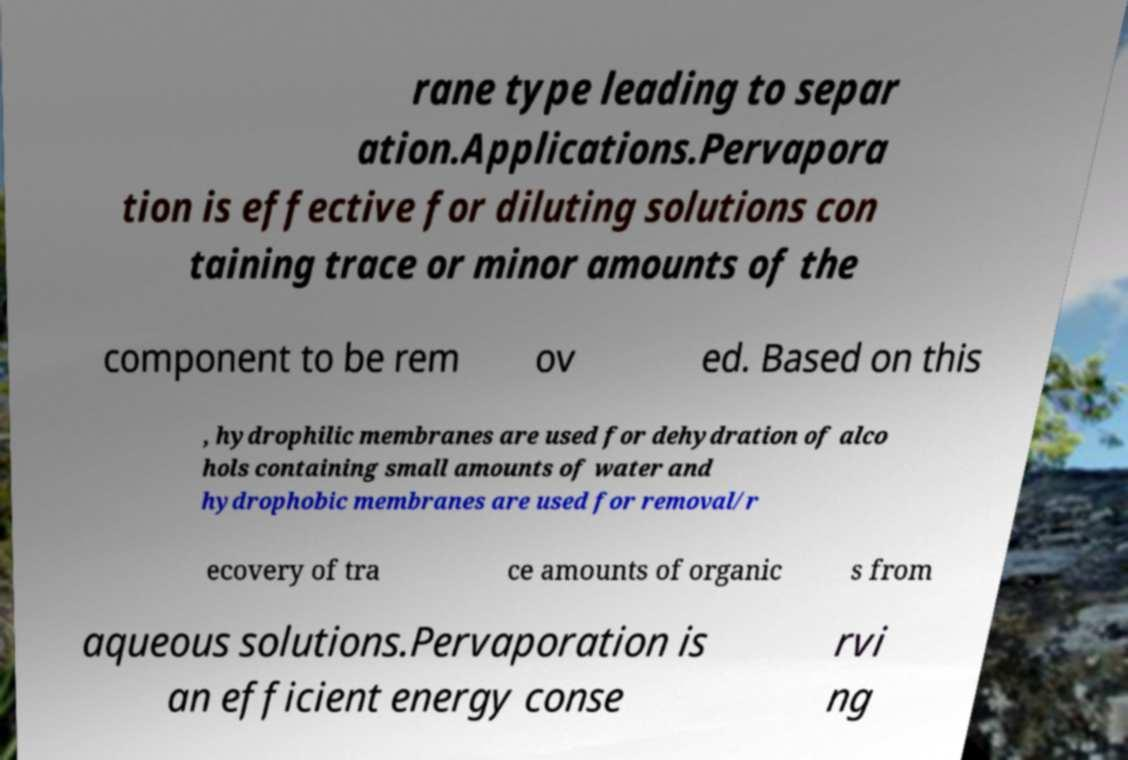Could you extract and type out the text from this image? rane type leading to separ ation.Applications.Pervapora tion is effective for diluting solutions con taining trace or minor amounts of the component to be rem ov ed. Based on this , hydrophilic membranes are used for dehydration of alco hols containing small amounts of water and hydrophobic membranes are used for removal/r ecovery of tra ce amounts of organic s from aqueous solutions.Pervaporation is an efficient energy conse rvi ng 